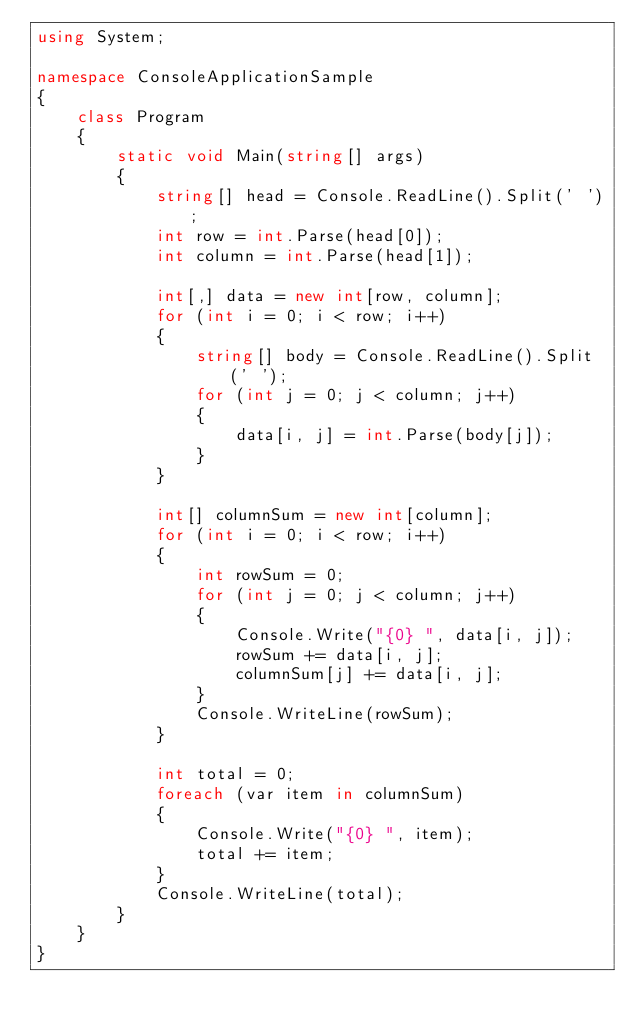Convert code to text. <code><loc_0><loc_0><loc_500><loc_500><_C#_>using System;

namespace ConsoleApplicationSample
{
    class Program
    {
        static void Main(string[] args)
        {
            string[] head = Console.ReadLine().Split(' ');
            int row = int.Parse(head[0]);
            int column = int.Parse(head[1]);

            int[,] data = new int[row, column];
            for (int i = 0; i < row; i++)
            {
                string[] body = Console.ReadLine().Split(' ');
                for (int j = 0; j < column; j++)
                {
                    data[i, j] = int.Parse(body[j]);
                }
            }

            int[] columnSum = new int[column];
            for (int i = 0; i < row; i++)
            {
                int rowSum = 0;
                for (int j = 0; j < column; j++)
                {
                    Console.Write("{0} ", data[i, j]);
                    rowSum += data[i, j];
                    columnSum[j] += data[i, j];
                }
                Console.WriteLine(rowSum);
            }

            int total = 0;
            foreach (var item in columnSum)
            {
                Console.Write("{0} ", item);
                total += item;
            }
            Console.WriteLine(total);
        }
    }
}</code> 